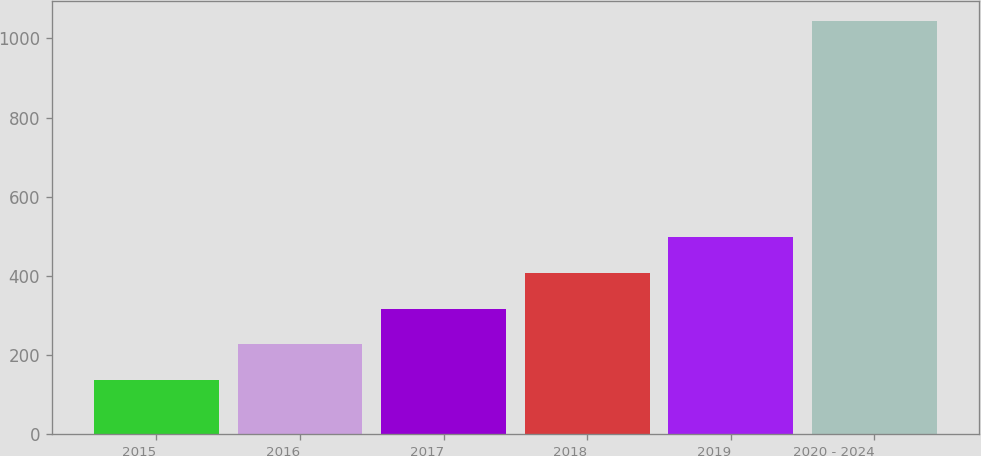Convert chart. <chart><loc_0><loc_0><loc_500><loc_500><bar_chart><fcel>2015<fcel>2016<fcel>2017<fcel>2018<fcel>2019<fcel>2020 - 2024<nl><fcel>136<fcel>226.7<fcel>317.4<fcel>408.1<fcel>498.8<fcel>1043<nl></chart> 